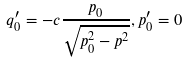<formula> <loc_0><loc_0><loc_500><loc_500>q _ { 0 } ^ { \prime } = - c \frac { p _ { 0 } } { \sqrt { p _ { 0 } ^ { 2 } - { p } ^ { 2 } } } , p _ { 0 } ^ { \prime } = 0</formula> 